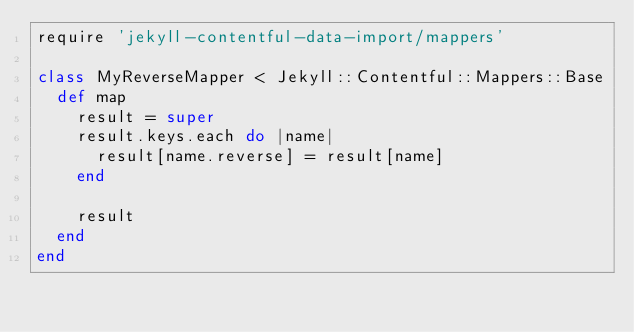<code> <loc_0><loc_0><loc_500><loc_500><_Ruby_>require 'jekyll-contentful-data-import/mappers'

class MyReverseMapper < Jekyll::Contentful::Mappers::Base
  def map
    result = super
    result.keys.each do |name|
      result[name.reverse] = result[name]
    end

    result
  end
end
</code> 